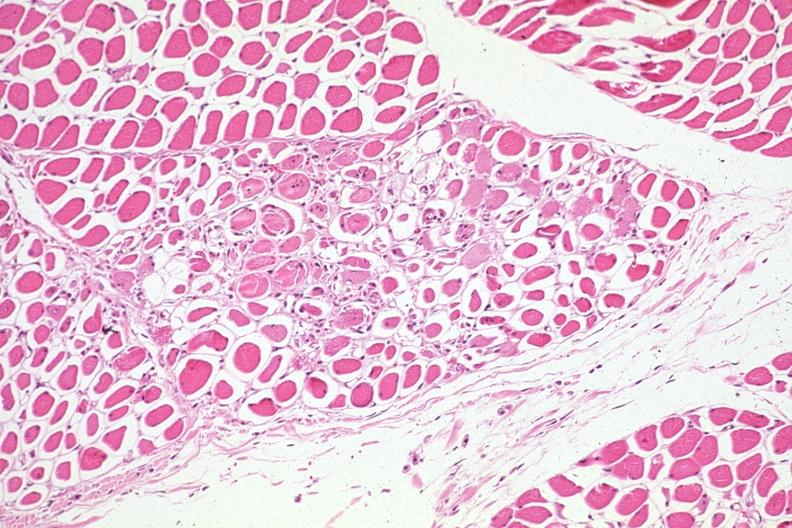what is present?
Answer the question using a single word or phrase. Soft tissue 